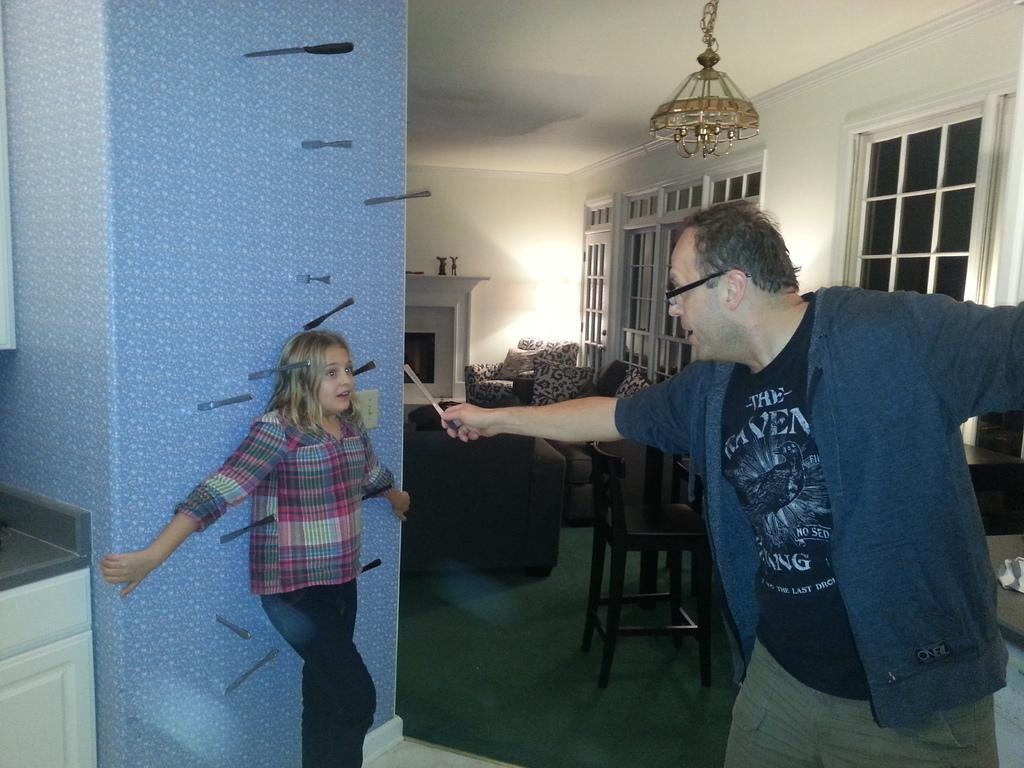How many people are visible in the image? There are people standing in the image. What is the man holding in his hand? A man is holding a knife in his hand. What type of egg is being cracked with the comb in the image? There is no egg or comb present in the image. Can you see any cobwebs in the image? There is no mention of cobwebs in the provided facts, so we cannot determine if they are present in the image. 